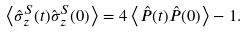<formula> <loc_0><loc_0><loc_500><loc_500>\left \langle \hat { \sigma } ^ { S } _ { z } ( t ) \hat { \sigma } ^ { S } _ { z } ( 0 ) \right \rangle = 4 \left \langle \hat { P } ( t ) \hat { P } ( 0 ) \right \rangle - 1 .</formula> 